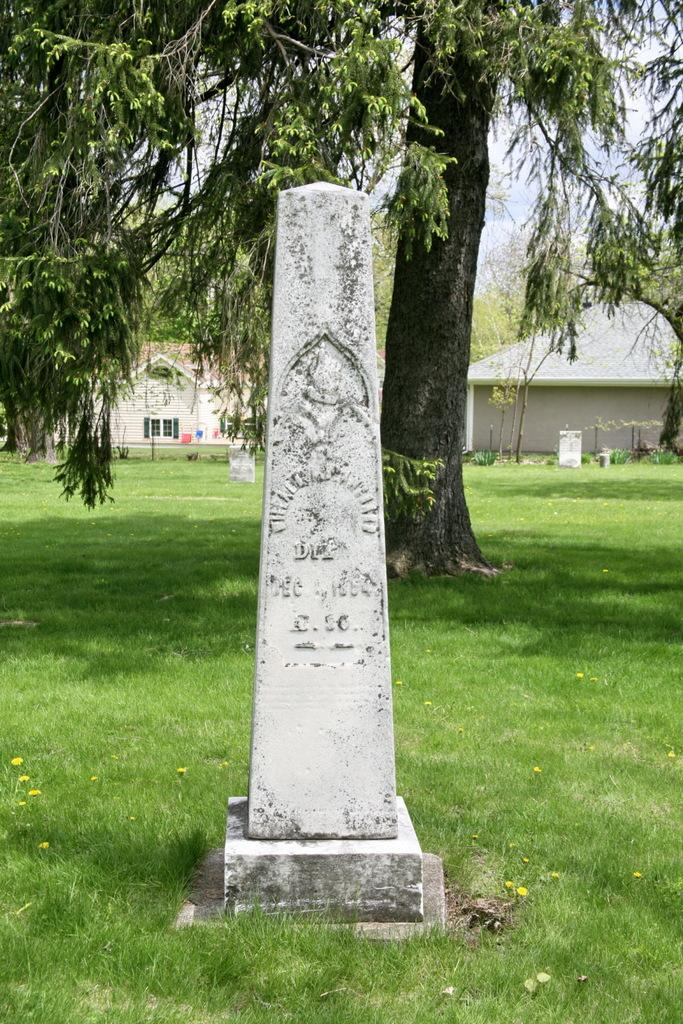What type of structure is depicted in the image? The image appears to be a memorial stone. What type of vegetation is present in the image? There is grass in the image. What other natural elements can be seen in the image? There is a tree with branches and leaves in the image. What can be seen in the distance in the image? In the background, there are houses with windows. How does the scale of the tree compare to the size of the houses in the image? The provided facts do not give any information about the size or scale of the tree or the houses, so it cannot be determined from the image. 